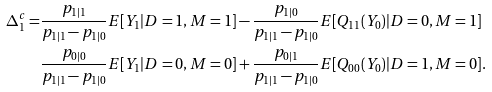Convert formula to latex. <formula><loc_0><loc_0><loc_500><loc_500>\Delta _ { 1 } ^ { c } = & \frac { p _ { 1 | 1 } } { p _ { 1 | 1 } - p _ { 1 | 0 } } E [ Y _ { 1 } | D = 1 , M = 1 ] - \frac { p _ { 1 | 0 } } { p _ { 1 | 1 } - p _ { 1 | 0 } } E [ Q _ { 1 1 } ( Y _ { 0 } ) | D = 0 , M = 1 ] \\ & \frac { p _ { 0 | 0 } } { p _ { 1 | 1 } - p _ { 1 | 0 } } E [ Y _ { 1 } | D = 0 , M = 0 ] + \frac { p _ { 0 | 1 } } { p _ { 1 | 1 } - p _ { 1 | 0 } } E [ Q _ { 0 0 } ( Y _ { 0 } ) | D = 1 , M = 0 ] .</formula> 